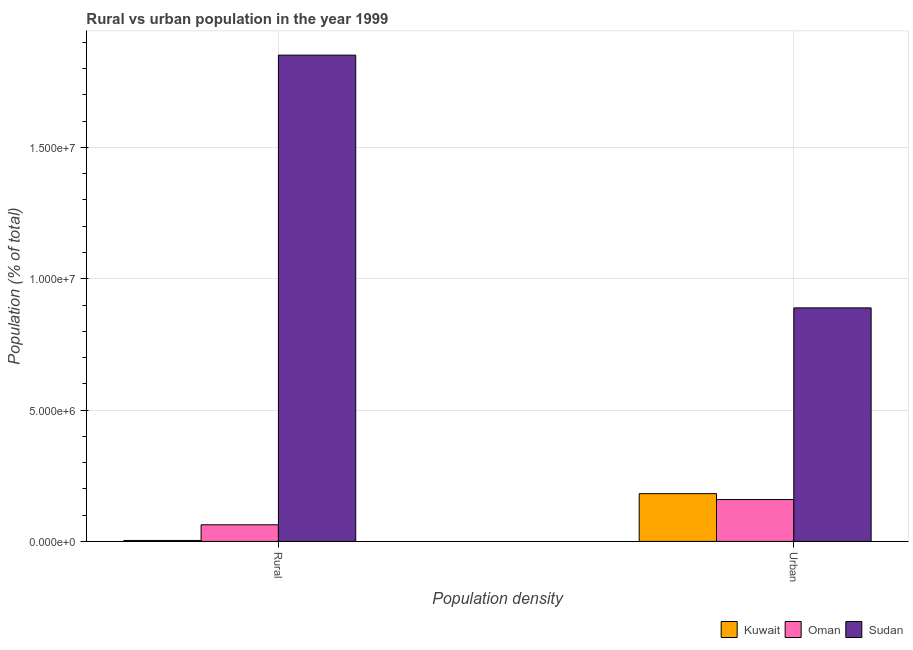How many different coloured bars are there?
Offer a terse response. 3. Are the number of bars per tick equal to the number of legend labels?
Offer a terse response. Yes. Are the number of bars on each tick of the X-axis equal?
Make the answer very short. Yes. How many bars are there on the 2nd tick from the right?
Your response must be concise. 3. What is the label of the 1st group of bars from the left?
Provide a succinct answer. Rural. What is the urban population density in Kuwait?
Offer a very short reply. 1.82e+06. Across all countries, what is the maximum urban population density?
Your response must be concise. 8.89e+06. Across all countries, what is the minimum rural population density?
Make the answer very short. 3.52e+04. In which country was the rural population density maximum?
Your answer should be compact. Sudan. In which country was the rural population density minimum?
Provide a short and direct response. Kuwait. What is the total rural population density in the graph?
Your answer should be very brief. 1.92e+07. What is the difference between the rural population density in Sudan and that in Oman?
Provide a succinct answer. 1.79e+07. What is the difference between the urban population density in Oman and the rural population density in Kuwait?
Make the answer very short. 1.56e+06. What is the average urban population density per country?
Provide a short and direct response. 4.10e+06. What is the difference between the rural population density and urban population density in Oman?
Ensure brevity in your answer.  -9.61e+05. What is the ratio of the rural population density in Kuwait to that in Oman?
Your answer should be very brief. 0.06. Is the urban population density in Oman less than that in Kuwait?
Offer a terse response. Yes. What does the 3rd bar from the left in Urban represents?
Offer a very short reply. Sudan. What does the 1st bar from the right in Urban represents?
Provide a succinct answer. Sudan. How many bars are there?
Offer a very short reply. 6. How many countries are there in the graph?
Ensure brevity in your answer.  3. What is the difference between two consecutive major ticks on the Y-axis?
Provide a succinct answer. 5.00e+06. Are the values on the major ticks of Y-axis written in scientific E-notation?
Give a very brief answer. Yes. Does the graph contain any zero values?
Offer a very short reply. No. Does the graph contain grids?
Keep it short and to the point. Yes. What is the title of the graph?
Your response must be concise. Rural vs urban population in the year 1999. What is the label or title of the X-axis?
Offer a terse response. Population density. What is the label or title of the Y-axis?
Give a very brief answer. Population (% of total). What is the Population (% of total) in Kuwait in Rural?
Make the answer very short. 3.52e+04. What is the Population (% of total) in Oman in Rural?
Keep it short and to the point. 6.32e+05. What is the Population (% of total) of Sudan in Rural?
Provide a succinct answer. 1.85e+07. What is the Population (% of total) in Kuwait in Urban?
Provide a short and direct response. 1.82e+06. What is the Population (% of total) of Oman in Urban?
Offer a very short reply. 1.59e+06. What is the Population (% of total) of Sudan in Urban?
Provide a short and direct response. 8.89e+06. Across all Population density, what is the maximum Population (% of total) of Kuwait?
Make the answer very short. 1.82e+06. Across all Population density, what is the maximum Population (% of total) of Oman?
Provide a short and direct response. 1.59e+06. Across all Population density, what is the maximum Population (% of total) in Sudan?
Provide a short and direct response. 1.85e+07. Across all Population density, what is the minimum Population (% of total) in Kuwait?
Provide a short and direct response. 3.52e+04. Across all Population density, what is the minimum Population (% of total) of Oman?
Make the answer very short. 6.32e+05. Across all Population density, what is the minimum Population (% of total) of Sudan?
Give a very brief answer. 8.89e+06. What is the total Population (% of total) in Kuwait in the graph?
Keep it short and to the point. 1.85e+06. What is the total Population (% of total) of Oman in the graph?
Provide a short and direct response. 2.23e+06. What is the total Population (% of total) of Sudan in the graph?
Offer a terse response. 2.74e+07. What is the difference between the Population (% of total) of Kuwait in Rural and that in Urban?
Offer a very short reply. -1.78e+06. What is the difference between the Population (% of total) in Oman in Rural and that in Urban?
Your answer should be very brief. -9.61e+05. What is the difference between the Population (% of total) of Sudan in Rural and that in Urban?
Your answer should be compact. 9.62e+06. What is the difference between the Population (% of total) of Kuwait in Rural and the Population (% of total) of Oman in Urban?
Give a very brief answer. -1.56e+06. What is the difference between the Population (% of total) of Kuwait in Rural and the Population (% of total) of Sudan in Urban?
Make the answer very short. -8.86e+06. What is the difference between the Population (% of total) in Oman in Rural and the Population (% of total) in Sudan in Urban?
Provide a short and direct response. -8.26e+06. What is the average Population (% of total) of Kuwait per Population density?
Offer a terse response. 9.27e+05. What is the average Population (% of total) in Oman per Population density?
Keep it short and to the point. 1.11e+06. What is the average Population (% of total) of Sudan per Population density?
Make the answer very short. 1.37e+07. What is the difference between the Population (% of total) of Kuwait and Population (% of total) of Oman in Rural?
Keep it short and to the point. -5.97e+05. What is the difference between the Population (% of total) in Kuwait and Population (% of total) in Sudan in Rural?
Your response must be concise. -1.85e+07. What is the difference between the Population (% of total) in Oman and Population (% of total) in Sudan in Rural?
Your answer should be very brief. -1.79e+07. What is the difference between the Population (% of total) in Kuwait and Population (% of total) in Oman in Urban?
Offer a very short reply. 2.25e+05. What is the difference between the Population (% of total) in Kuwait and Population (% of total) in Sudan in Urban?
Give a very brief answer. -7.07e+06. What is the difference between the Population (% of total) in Oman and Population (% of total) in Sudan in Urban?
Provide a short and direct response. -7.30e+06. What is the ratio of the Population (% of total) of Kuwait in Rural to that in Urban?
Provide a short and direct response. 0.02. What is the ratio of the Population (% of total) of Oman in Rural to that in Urban?
Provide a succinct answer. 0.4. What is the ratio of the Population (% of total) of Sudan in Rural to that in Urban?
Provide a short and direct response. 2.08. What is the difference between the highest and the second highest Population (% of total) of Kuwait?
Make the answer very short. 1.78e+06. What is the difference between the highest and the second highest Population (% of total) of Oman?
Your response must be concise. 9.61e+05. What is the difference between the highest and the second highest Population (% of total) in Sudan?
Provide a succinct answer. 9.62e+06. What is the difference between the highest and the lowest Population (% of total) of Kuwait?
Your response must be concise. 1.78e+06. What is the difference between the highest and the lowest Population (% of total) in Oman?
Give a very brief answer. 9.61e+05. What is the difference between the highest and the lowest Population (% of total) of Sudan?
Ensure brevity in your answer.  9.62e+06. 